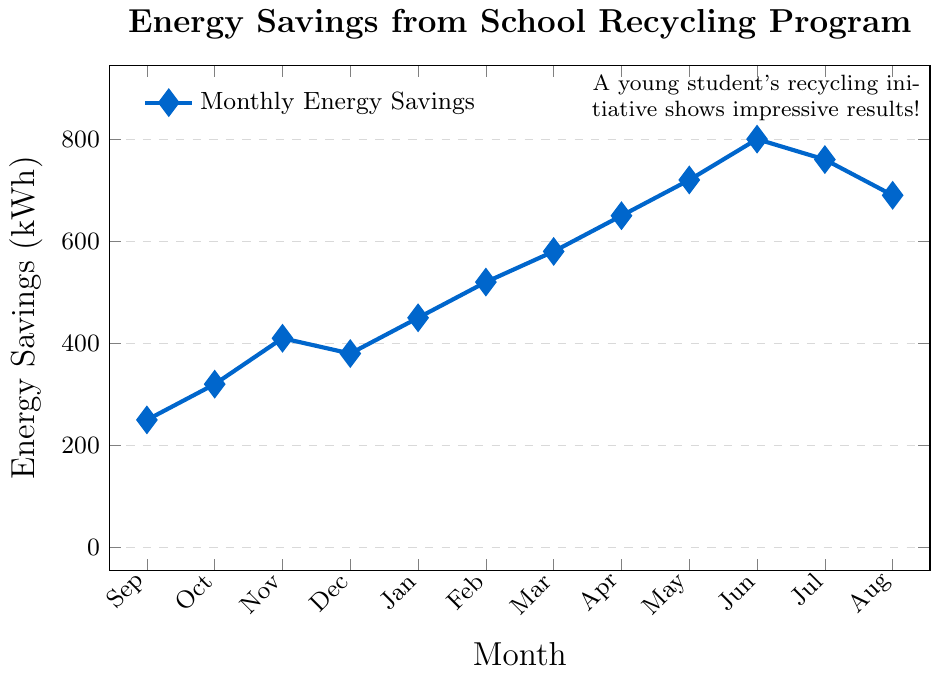What is the total energy savings from September to November? To find the total energy savings from September to November, sum the energy savings for each month: September (250 kWh), October (320 kWh), and November (410 kWh). So, 250 + 320 + 410 = 980 kWh
Answer: 980 kWh Which month had the highest energy savings, and what was the value? By comparing the energy savings for each month, June had the highest savings with 800 kWh.
Answer: June, 800 kWh How much more energy was saved in March compared to September? To determine the difference, subtract the energy savings in September from those in March: March (580 kWh) - September (250 kWh) = 330 kWh
Answer: 330 kWh In which month did energy savings decrease compared to the previous month? By examining the chart, the energy savings decreased in December (380 kWh) compared to November (410 kWh), and in August (690 kWh) compared to July (760 kWh).
Answer: December, August What is the average monthly energy savings across the entire year? Total energy savings for the year: 250 + 320 + 410 + 380 + 450 + 520 + 580 + 650 + 720 + 800 + 760 + 690 = 6530 kWh. Average = 6530 kWh / 12 months = 544.17 kWh
Answer: 544.17 kWh What are the energy savings trends from January to March? The energy savings from January (450 kWh) to February (520 kWh) to March (580 kWh) show an increasing trend.
Answer: Increasing trend Which two months had the closest energy savings values, and what were those values? By comparing the energy savings, July (760 kWh) and August (690 kWh) had close values with a difference of 70 kWh.
Answer: July and August; 760 kWh and 690 kWh Calculate the percentage increase in energy savings from September to June. Percentage increase = [(June - September) / September] * 100 = [(800 - 250) / 250] * 100 = 220%.
Answer: 220% Which season (Fall, Winter, Spring, Summer) had the highest total energy savings? Fall (Sept-Nov): 250 + 320 + 410 = 980 kWh, Winter (Dec-Feb): 380 + 450 + 520 = 1350 kWh, Spring (Mar-May): 580 + 650 + 720 = 1950 kWh, Summer (Jun-Aug): 800 + 760 + 690 = 2250 kWh. Summer had the highest total energy savings.
Answer: Summer When did the student’s recycling initiative start showing a significant upward trend in energy savings? The significant upward trend starts from January (450 kWh) onward.
Answer: January 